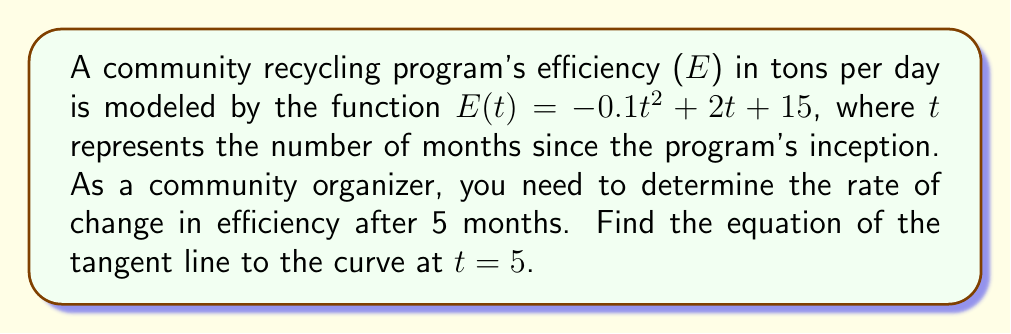Solve this math problem. To find the equation of the tangent line, we need to follow these steps:

1. Calculate the y-coordinate (E-value) at t = 5:
   $E(5) = -0.1(5)^2 + 2(5) + 15$
   $= -0.1(25) + 10 + 15$
   $= -2.5 + 25$
   $= 22.5$

2. Find the derivative of E(t):
   $E'(t) = \frac{d}{dt}(-0.1t^2 + 2t + 15)$
   $= -0.2t + 2$

3. Calculate the slope (m) at t = 5 using the derivative:
   $E'(5) = -0.2(5) + 2 = -1 + 2 = 1$

4. Use the point-slope form of a line to write the equation:
   $y - y_1 = m(x - x_1)$
   Where $(x_1, y_1) = (5, 22.5)$ and $m = 1$

   $y - 22.5 = 1(x - 5)$

5. Simplify to slope-intercept form:
   $y = 1(x - 5) + 22.5$
   $y = x - 5 + 22.5$
   $y = x + 17.5$

Therefore, the equation of the tangent line is $y = x + 17.5$.
Answer: $y = x + 17.5$ 